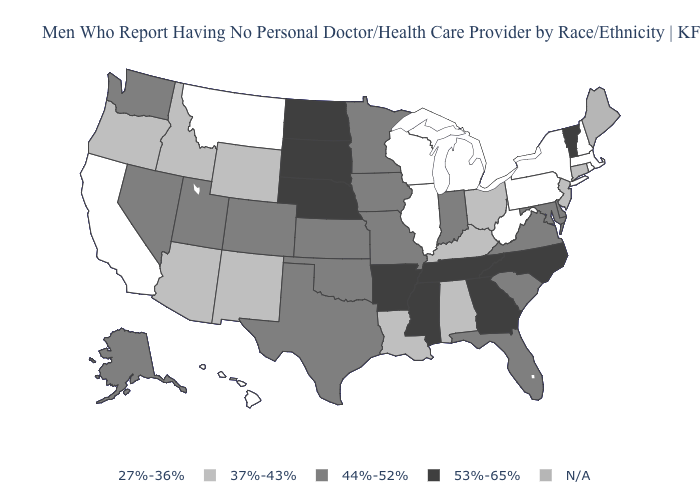What is the value of Iowa?
Quick response, please. 44%-52%. What is the value of Minnesota?
Answer briefly. 44%-52%. What is the lowest value in the MidWest?
Keep it brief. 27%-36%. Name the states that have a value in the range 27%-36%?
Be succinct. California, Hawaii, Illinois, Massachusetts, Michigan, Montana, New Hampshire, New York, Pennsylvania, Rhode Island, West Virginia, Wisconsin. Does Pennsylvania have the highest value in the Northeast?
Give a very brief answer. No. What is the highest value in states that border Maryland?
Quick response, please. 44%-52%. What is the lowest value in the USA?
Short answer required. 27%-36%. Does the first symbol in the legend represent the smallest category?
Answer briefly. Yes. Among the states that border Wyoming , which have the highest value?
Keep it brief. Nebraska, South Dakota. Which states hav the highest value in the West?
Write a very short answer. Alaska, Colorado, Nevada, Utah, Washington. What is the lowest value in states that border Arkansas?
Keep it brief. 37%-43%. Name the states that have a value in the range 44%-52%?
Concise answer only. Alaska, Colorado, Delaware, Florida, Indiana, Iowa, Kansas, Maryland, Minnesota, Missouri, Nevada, Oklahoma, South Carolina, Texas, Utah, Virginia, Washington. Does Washington have the lowest value in the USA?
Quick response, please. No. Name the states that have a value in the range 44%-52%?
Keep it brief. Alaska, Colorado, Delaware, Florida, Indiana, Iowa, Kansas, Maryland, Minnesota, Missouri, Nevada, Oklahoma, South Carolina, Texas, Utah, Virginia, Washington. 